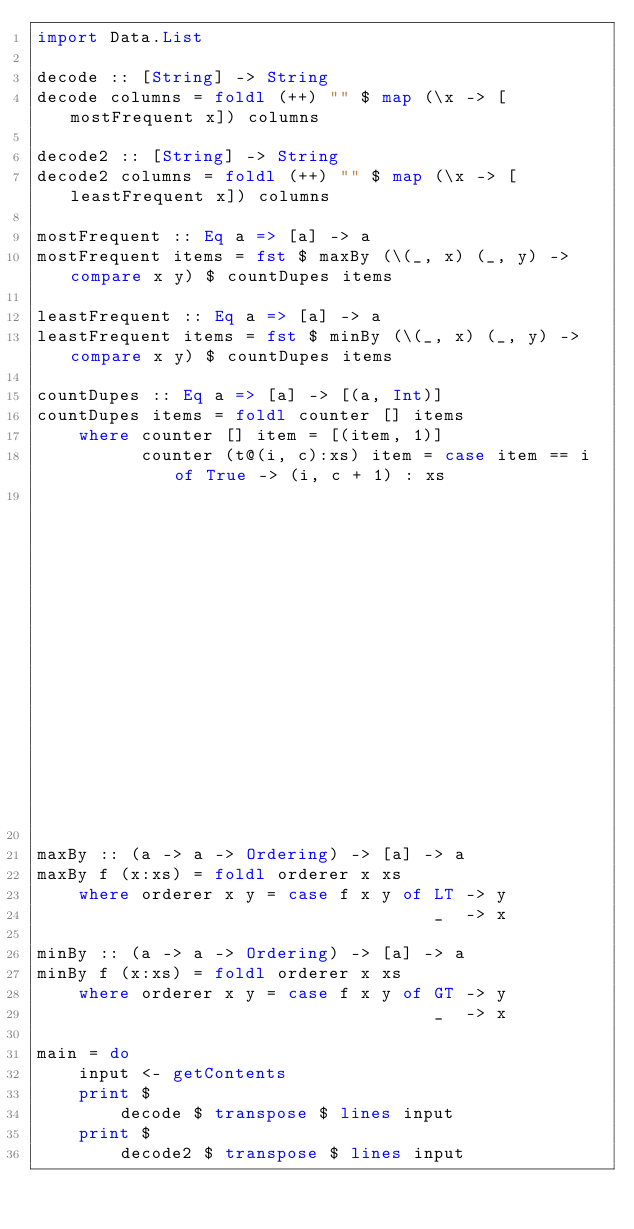Convert code to text. <code><loc_0><loc_0><loc_500><loc_500><_Haskell_>import Data.List

decode :: [String] -> String
decode columns = foldl (++) "" $ map (\x -> [mostFrequent x]) columns

decode2 :: [String] -> String
decode2 columns = foldl (++) "" $ map (\x -> [leastFrequent x]) columns

mostFrequent :: Eq a => [a] -> a
mostFrequent items = fst $ maxBy (\(_, x) (_, y) -> compare x y) $ countDupes items

leastFrequent :: Eq a => [a] -> a
leastFrequent items = fst $ minBy (\(_, x) (_, y) -> compare x y) $ countDupes items

countDupes :: Eq a => [a] -> [(a, Int)]
countDupes items = foldl counter [] items
    where counter [] item = [(item, 1)]
          counter (t@(i, c):xs) item = case item == i of True -> (i, c + 1) : xs
                                                         _    -> t : (counter xs item)

maxBy :: (a -> a -> Ordering) -> [a] -> a
maxBy f (x:xs) = foldl orderer x xs
    where orderer x y = case f x y of LT -> y
                                      _  -> x

minBy :: (a -> a -> Ordering) -> [a] -> a
minBy f (x:xs) = foldl orderer x xs
    where orderer x y = case f x y of GT -> y
                                      _  -> x

main = do
    input <- getContents
    print $
        decode $ transpose $ lines input
    print $
        decode2 $ transpose $ lines input
</code> 